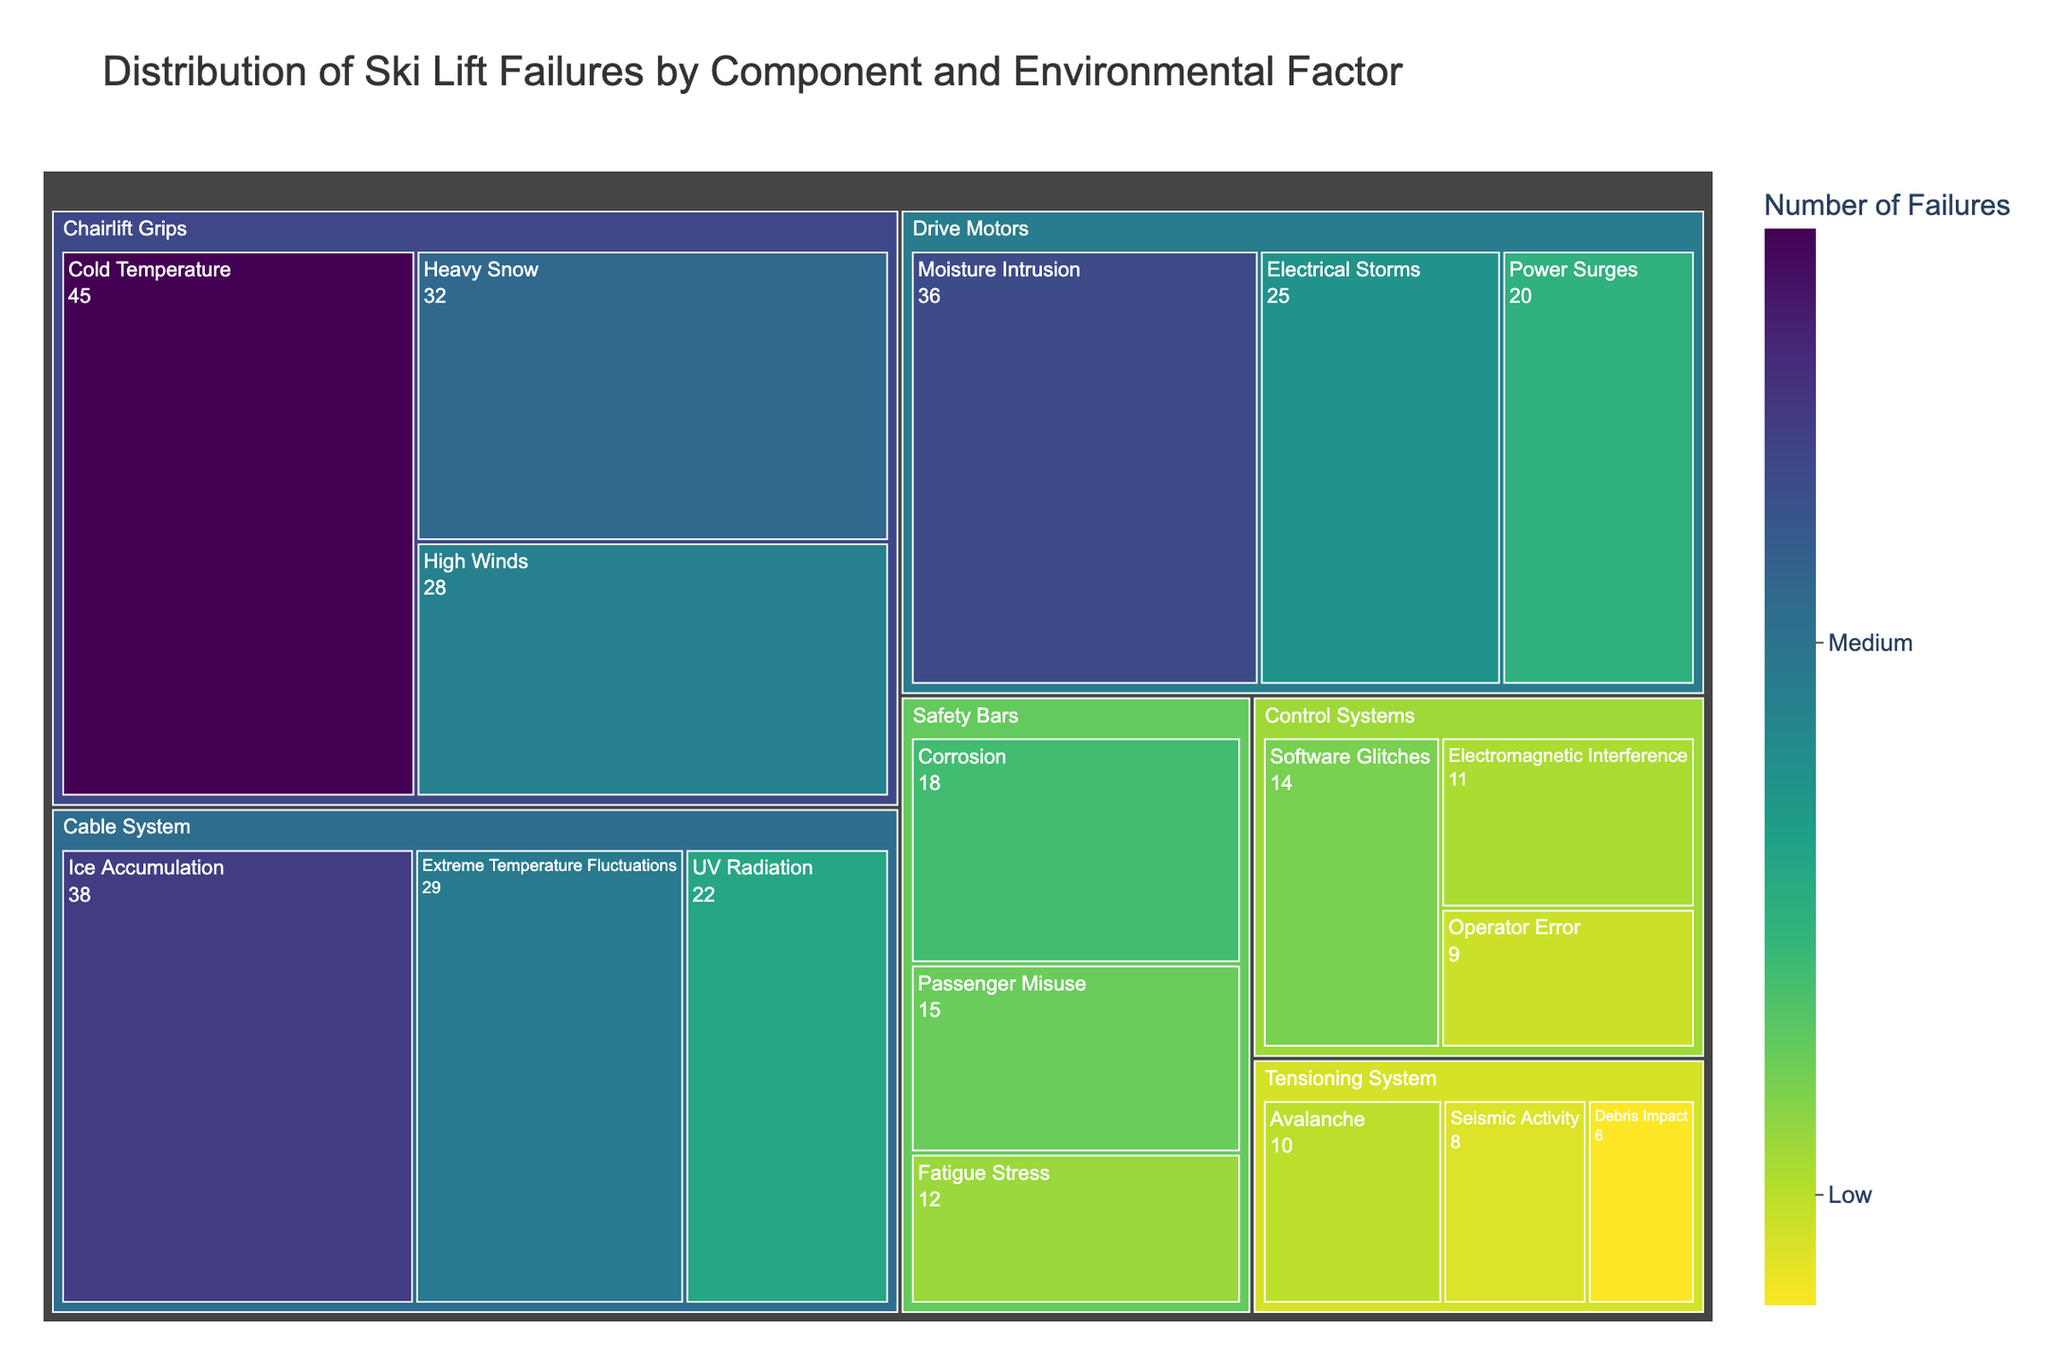What's the title of the treemap? The title of the treemap is displayed at the top of the figure, providing an overview of what the data represents.
Answer: Distribution of Ski Lift Failures by Component and Environmental Factor Which environmental factor caused the most failures for 'Chairlift Grips'? To determine this, look at the nested sections within 'Chairlift Grips'. The section with the highest number in 'Failures' indicates the most frequent cause.
Answer: Cold Temperature How many environmental factors are associated with the 'Tensioning System' component? Check the treemap sectors under 'Tensioning System'; each unique label here represents a different environmental factor.
Answer: 3 Which component has failures caused by 'Electrical Storms'? Identify the section labeled 'Electrical Storms' and trace back to the parent component labeled.
Answer: Drive Motors What is the total number of failures related to 'Control Systems'? Sum the values of all environmental factors listed under 'Control Systems'. These values are 14 (Software Glitches) + 11 (Electromagnetic Interference) + 9 (Operator Error).
Answer: 34 Which component has the least number of failures caused by a single environmental factor? Compare the smallest failure values across all components. The smallest value in the dataset provided is '6' for 'Tensioning System' caused by 'Debris Impact'.
Answer: Tensioning System (Debris Impact) Compare the number of failures due to 'Cold Temperature' for 'Chairlift Grips' and 'Ice Accumulation' for 'Cable System'. Which one is higher? Compare the numbers shown for 'Cold Temperature' under 'Chairlift Grips' and 'Ice Accumulation' under 'Cable System'. 'Cold Temperature' has 45 failures; 'Ice Accumulation' has 38 failures.
Answer: Cold Temperature for Chairlift Grips What range is assigned to the color scale in the treemap? The color scale is defined by specific buckets representing distinct ranges of failures. Refer to the color legend that shows the range labels.
Answer: Low, Medium, High What's the difference in the number of failures between 'High Winds' for 'Chairlift Grips' and 'Power Surges' for 'Drive Motors'? Subtract the failures associated with 'Power Surges' (20) from those associated with 'High Winds' (28): 28 - 20.
Answer: 8 